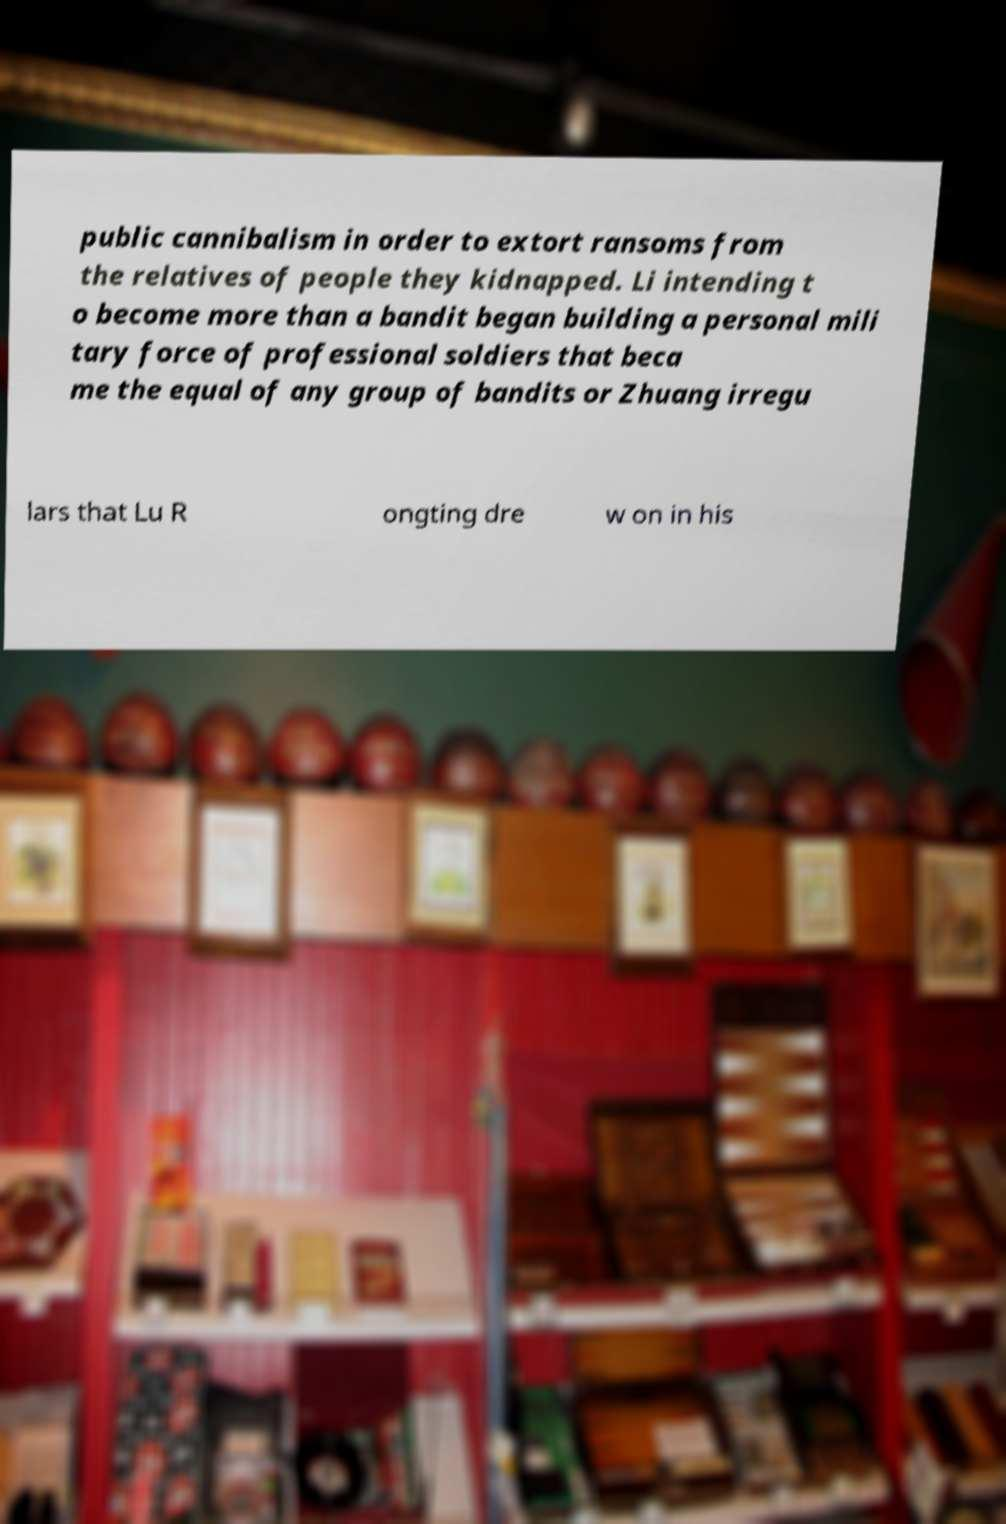Could you assist in decoding the text presented in this image and type it out clearly? public cannibalism in order to extort ransoms from the relatives of people they kidnapped. Li intending t o become more than a bandit began building a personal mili tary force of professional soldiers that beca me the equal of any group of bandits or Zhuang irregu lars that Lu R ongting dre w on in his 